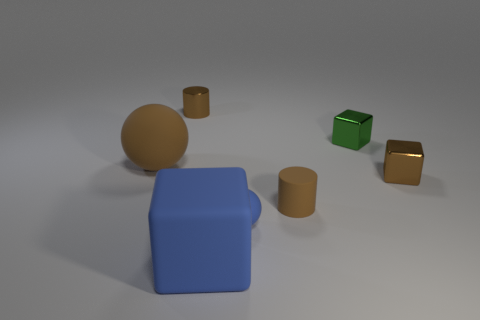Add 2 big cyan rubber cubes. How many objects exist? 9 Subtract all cubes. How many objects are left? 4 Subtract all large blue things. Subtract all tiny green things. How many objects are left? 5 Add 6 small brown metal blocks. How many small brown metal blocks are left? 7 Add 4 big matte balls. How many big matte balls exist? 5 Subtract 1 brown cubes. How many objects are left? 6 